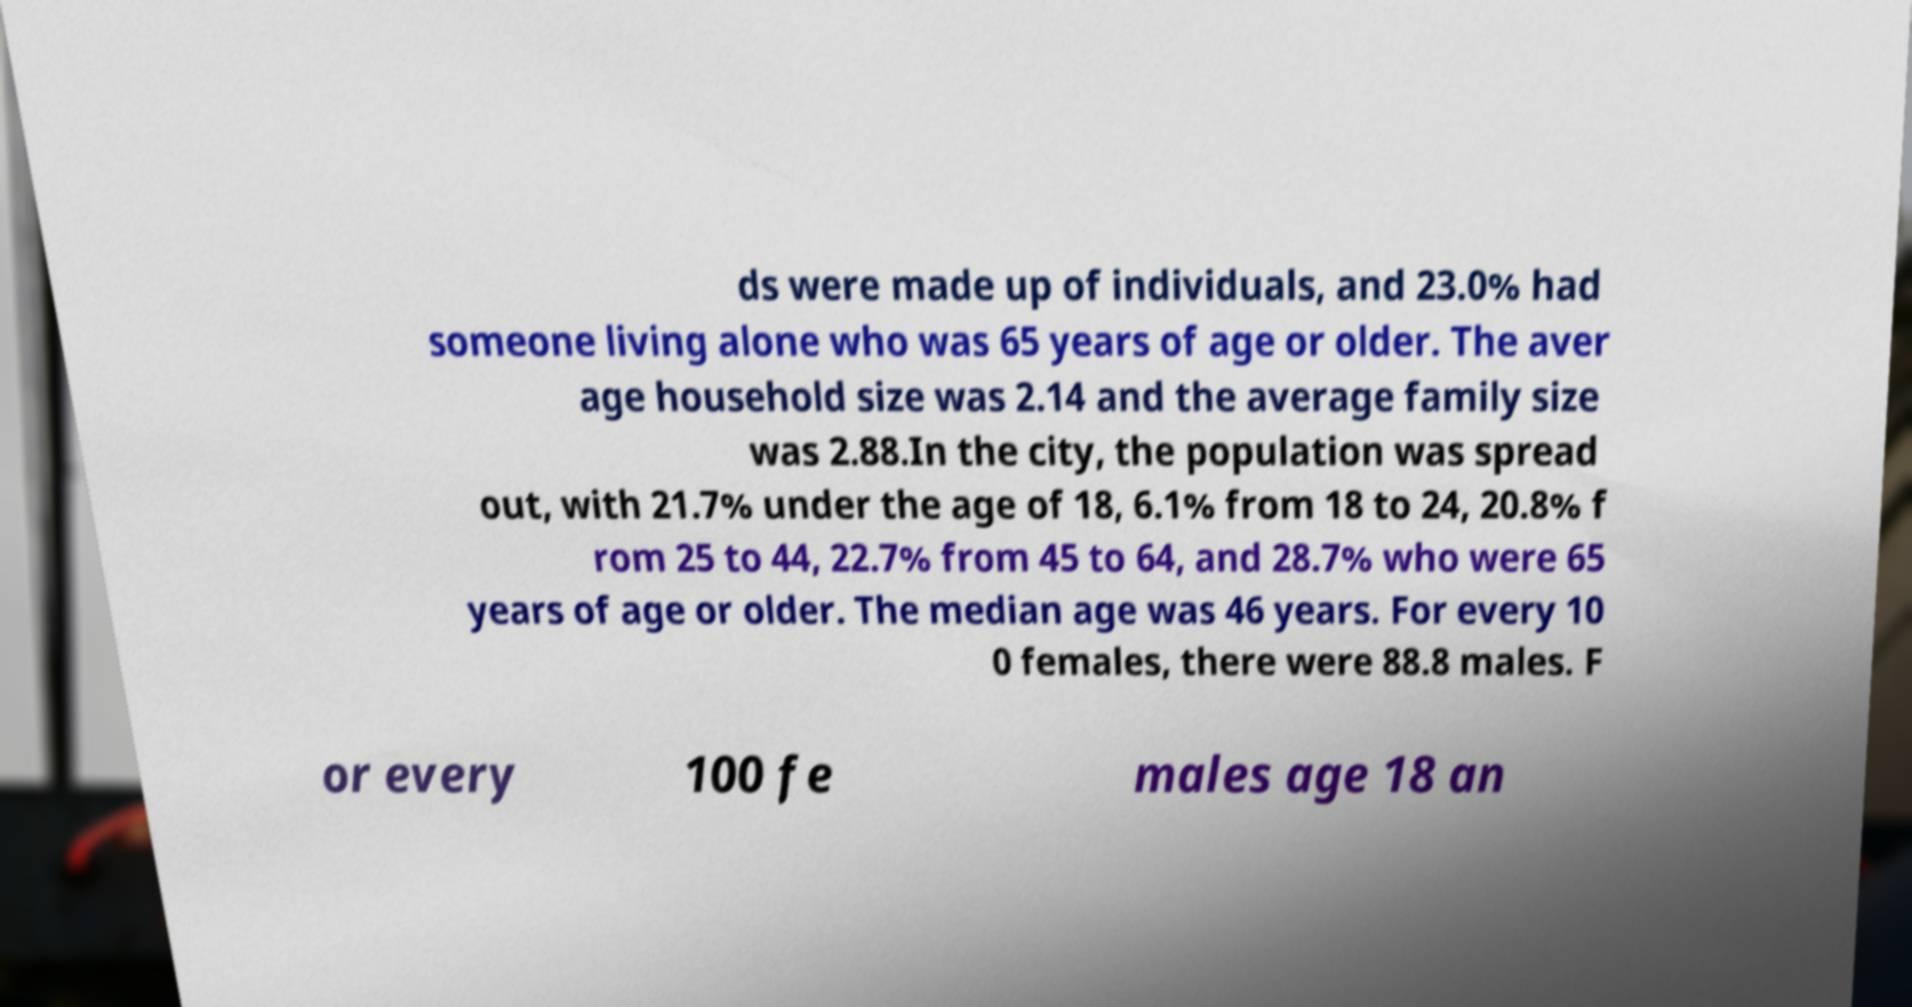Please identify and transcribe the text found in this image. ds were made up of individuals, and 23.0% had someone living alone who was 65 years of age or older. The aver age household size was 2.14 and the average family size was 2.88.In the city, the population was spread out, with 21.7% under the age of 18, 6.1% from 18 to 24, 20.8% f rom 25 to 44, 22.7% from 45 to 64, and 28.7% who were 65 years of age or older. The median age was 46 years. For every 10 0 females, there were 88.8 males. F or every 100 fe males age 18 an 